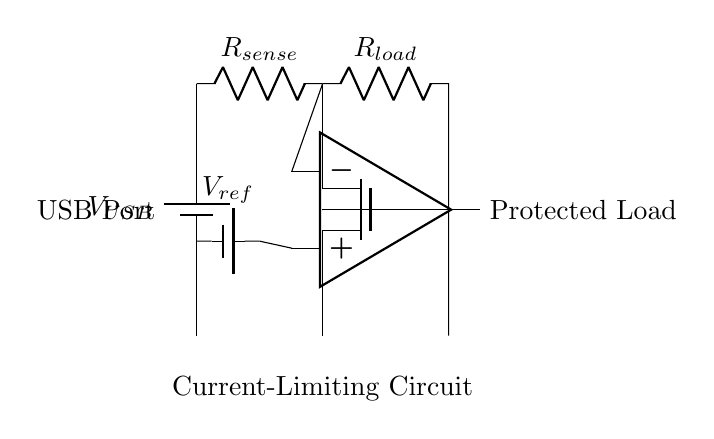What is the voltage source used in this circuit? The voltage source used is the USB power supply, labeled as V_USB in the diagram. This provides the necessary voltage for the current-limiting circuit to operate.
Answer: USB power supply What component senses the current in this circuit? The component that senses the current is the resistor labeled R_sense. This resistor is placed in series with the load and allows the circuit to monitor the current flowing through it.
Answer: R_sense How does the MOSFET control the current? The MOSFET controls the current by being governed by the output of the op-amp. When the voltage at the inverting terminal exceeds the non-inverting terminal, the op-amp's output will turn off the MOSFET, limiting the current to the load.
Answer: By turning on/off What is the primary purpose of the comparator in this circuit? The primary purpose of the comparator is to compare the voltage across the current sense resistor (R_sense) with a reference voltage (V_ref). This comparison allows the circuit to determine if the current is too high and to react accordingly by controlling the MOSFET.
Answer: To compare voltages What is the reference voltage voltage source in the circuit? The reference voltage source is labeled V_ref. It is used to set a threshold against which the voltage drop across R_sense is measured, determining when to limit the current.
Answer: V_ref 